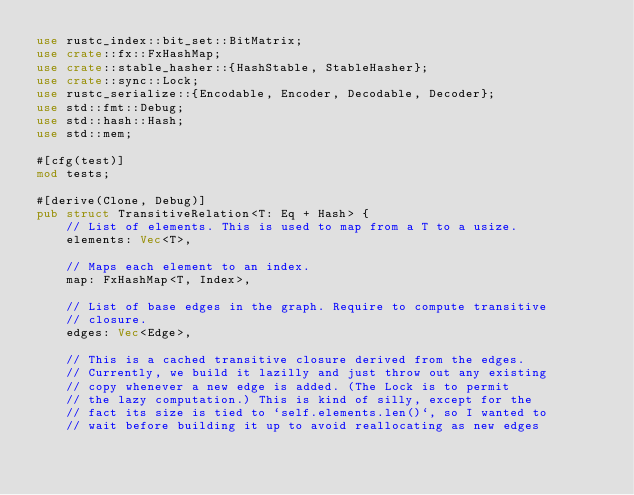<code> <loc_0><loc_0><loc_500><loc_500><_Rust_>use rustc_index::bit_set::BitMatrix;
use crate::fx::FxHashMap;
use crate::stable_hasher::{HashStable, StableHasher};
use crate::sync::Lock;
use rustc_serialize::{Encodable, Encoder, Decodable, Decoder};
use std::fmt::Debug;
use std::hash::Hash;
use std::mem;

#[cfg(test)]
mod tests;

#[derive(Clone, Debug)]
pub struct TransitiveRelation<T: Eq + Hash> {
    // List of elements. This is used to map from a T to a usize.
    elements: Vec<T>,

    // Maps each element to an index.
    map: FxHashMap<T, Index>,

    // List of base edges in the graph. Require to compute transitive
    // closure.
    edges: Vec<Edge>,

    // This is a cached transitive closure derived from the edges.
    // Currently, we build it lazilly and just throw out any existing
    // copy whenever a new edge is added. (The Lock is to permit
    // the lazy computation.) This is kind of silly, except for the
    // fact its size is tied to `self.elements.len()`, so I wanted to
    // wait before building it up to avoid reallocating as new edges</code> 